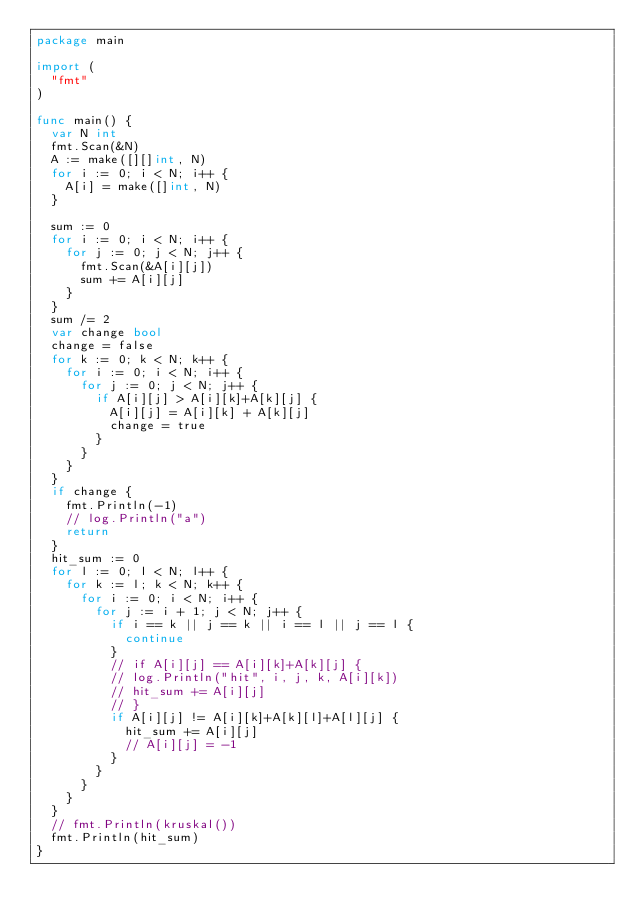Convert code to text. <code><loc_0><loc_0><loc_500><loc_500><_Go_>package main

import (
	"fmt"
)

func main() {
	var N int
	fmt.Scan(&N)
	A := make([][]int, N)
	for i := 0; i < N; i++ {
		A[i] = make([]int, N)
	}

	sum := 0
	for i := 0; i < N; i++ {
		for j := 0; j < N; j++ {
			fmt.Scan(&A[i][j])
			sum += A[i][j]
		}
	}
	sum /= 2
	var change bool
	change = false
	for k := 0; k < N; k++ {
		for i := 0; i < N; i++ {
			for j := 0; j < N; j++ {
				if A[i][j] > A[i][k]+A[k][j] {
					A[i][j] = A[i][k] + A[k][j]
					change = true
				}
			}
		}
	}
	if change {
		fmt.Println(-1)
		// log.Println("a")
		return
	}
	hit_sum := 0
	for l := 0; l < N; l++ {
		for k := l; k < N; k++ {
			for i := 0; i < N; i++ {
				for j := i + 1; j < N; j++ {
					if i == k || j == k || i == l || j == l {
						continue
					}
					// if A[i][j] == A[i][k]+A[k][j] {
					// log.Println("hit", i, j, k, A[i][k])
					// hit_sum += A[i][j]
					// }
					if A[i][j] != A[i][k]+A[k][l]+A[l][j] {
						hit_sum += A[i][j]
						// A[i][j] = -1
					}
				}
			}
		}
	}
	// fmt.Println(kruskal())
	fmt.Println(hit_sum)
}
</code> 